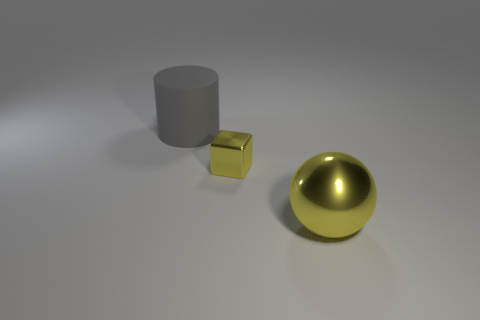Is there any other thing that has the same material as the big cylinder?
Provide a short and direct response. No. There is a object that is both in front of the gray object and to the left of the large shiny thing; how big is it?
Your answer should be compact. Small. There is a yellow thing that is to the left of the sphere; does it have the same shape as the gray rubber thing?
Offer a very short reply. No. There is a yellow metal object that is left of the big yellow ball in front of the metallic object that is on the left side of the large ball; how big is it?
Give a very brief answer. Small. There is a metal ball that is the same color as the small metal block; what size is it?
Your answer should be very brief. Large. How many things are either large yellow metallic cylinders or large things?
Ensure brevity in your answer.  2. There is a object that is to the left of the large yellow object and on the right side of the gray rubber cylinder; what is its shape?
Offer a terse response. Cube. Are there any small yellow metal cubes on the left side of the big yellow metal ball?
Ensure brevity in your answer.  Yes. How many cubes are yellow shiny objects or large purple rubber objects?
Provide a succinct answer. 1. Is the shape of the big rubber thing the same as the large yellow thing?
Offer a very short reply. No. 